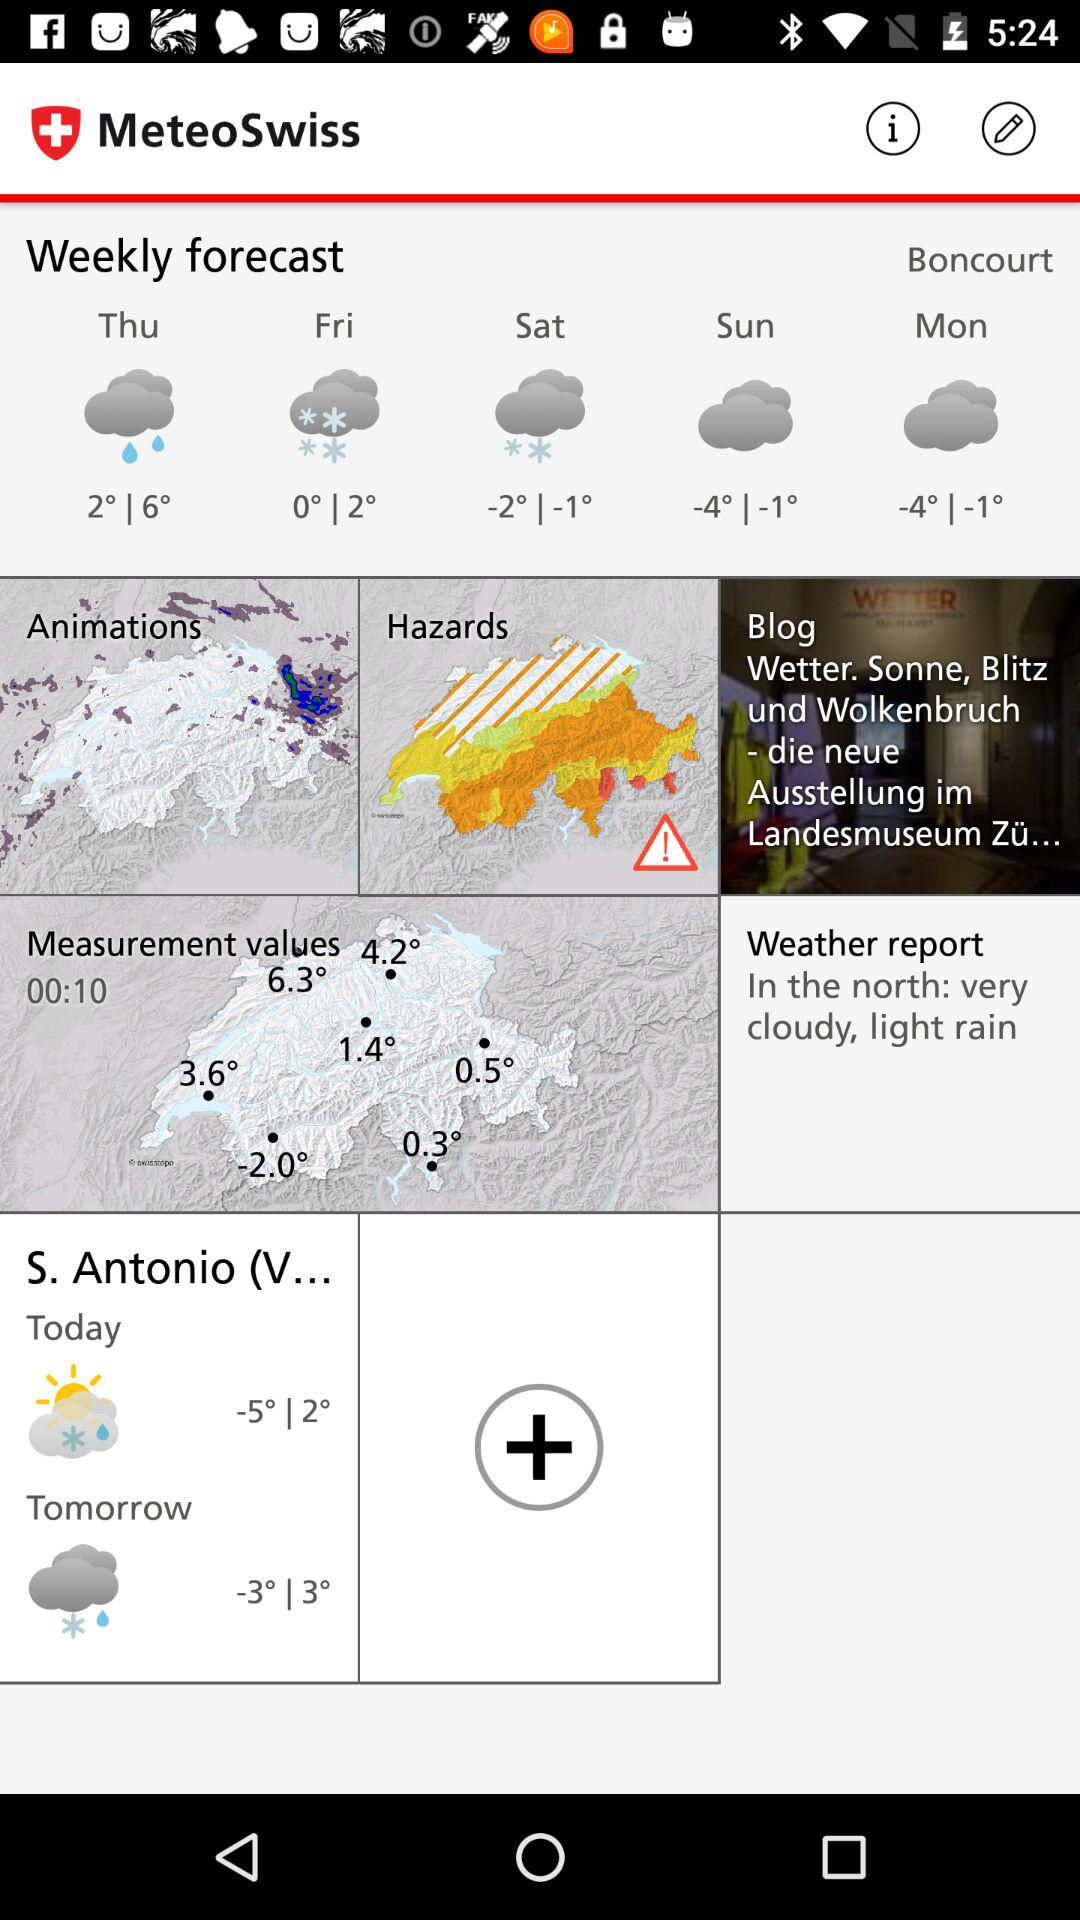What is the temperature today? The temperature today ranges from -5 degrees to 2 degrees. 